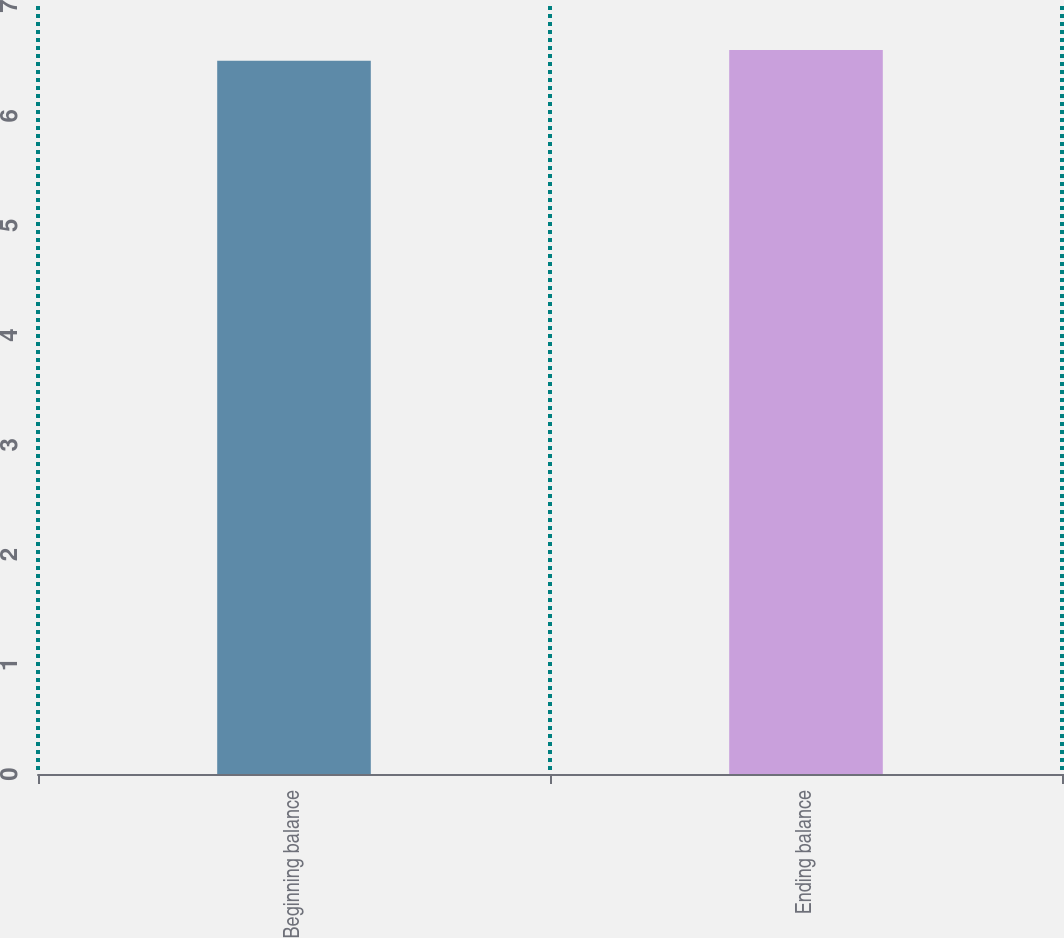Convert chart to OTSL. <chart><loc_0><loc_0><loc_500><loc_500><bar_chart><fcel>Beginning balance<fcel>Ending balance<nl><fcel>6.5<fcel>6.6<nl></chart> 